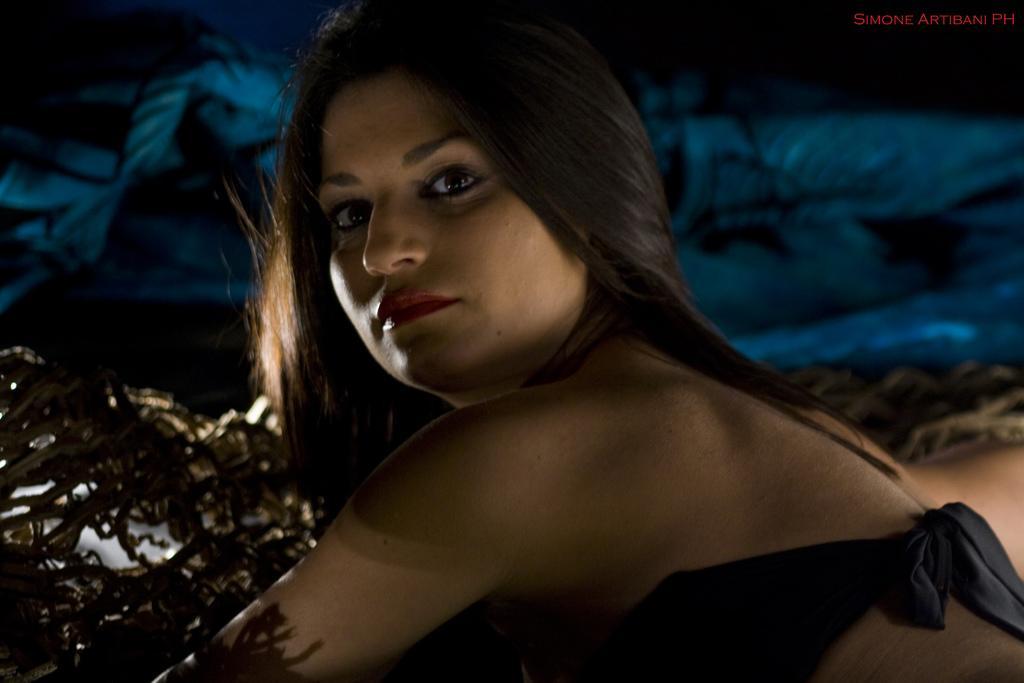Could you give a brief overview of what you see in this image? In this image we can see a person and an object near the person and a blurry background. 